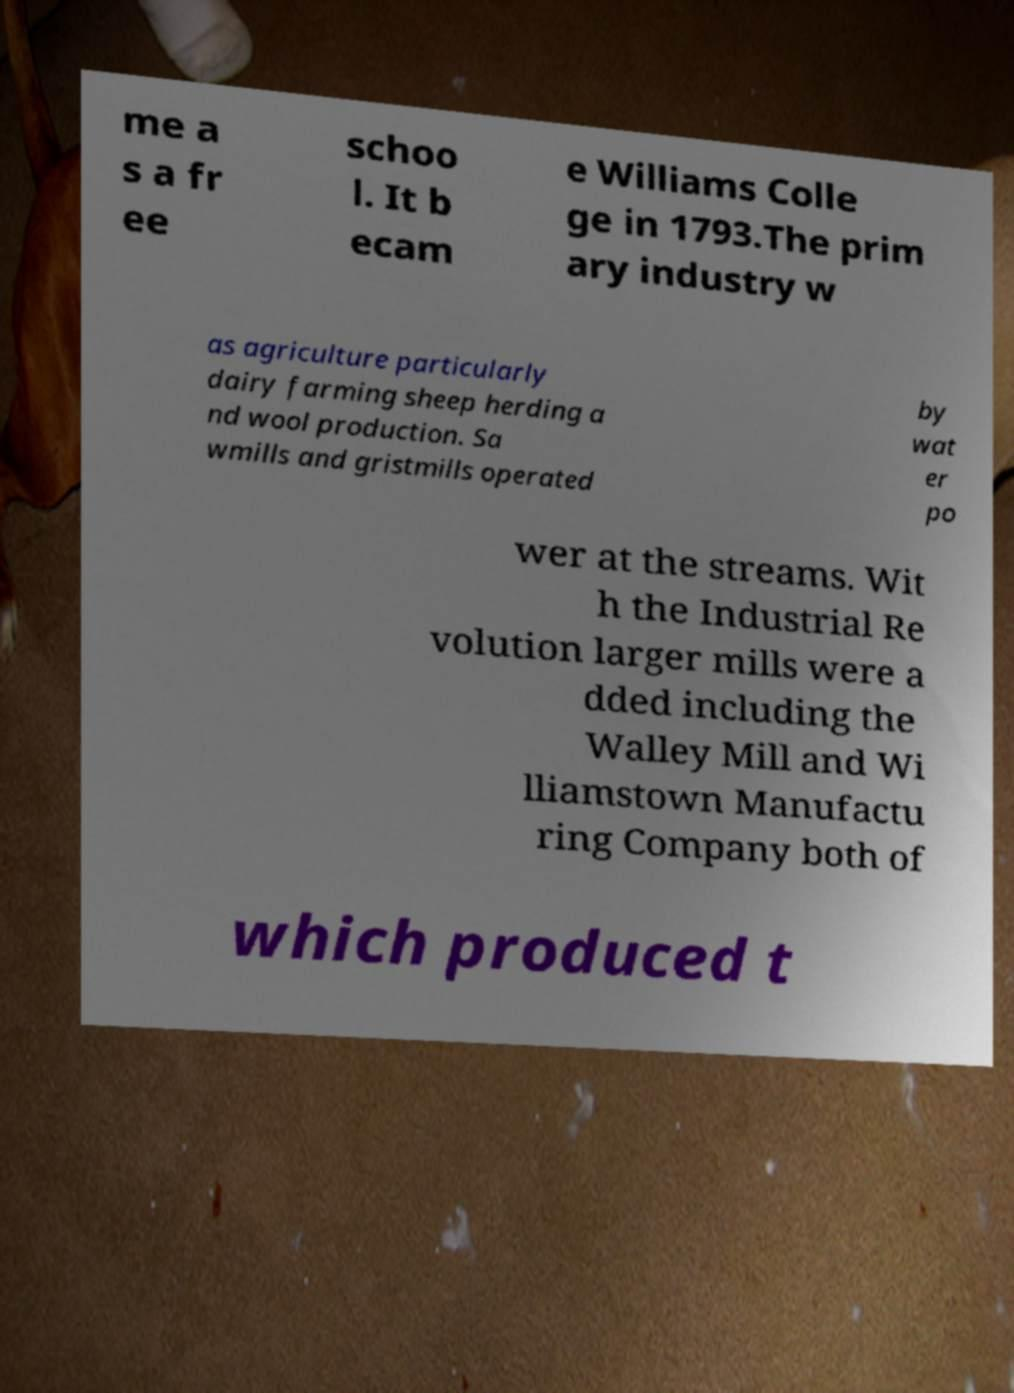Could you assist in decoding the text presented in this image and type it out clearly? me a s a fr ee schoo l. It b ecam e Williams Colle ge in 1793.The prim ary industry w as agriculture particularly dairy farming sheep herding a nd wool production. Sa wmills and gristmills operated by wat er po wer at the streams. Wit h the Industrial Re volution larger mills were a dded including the Walley Mill and Wi lliamstown Manufactu ring Company both of which produced t 